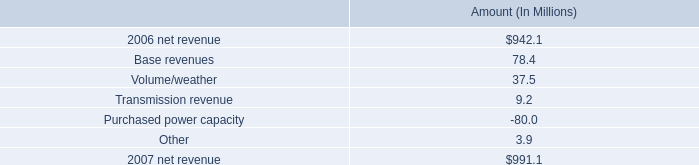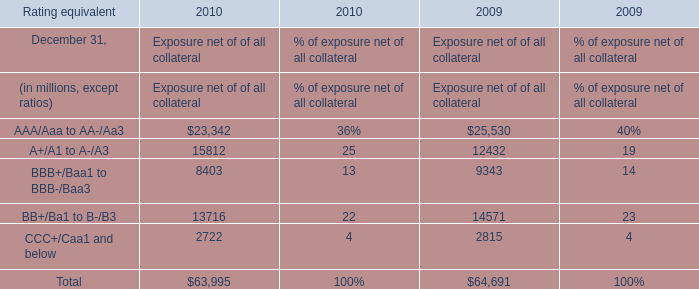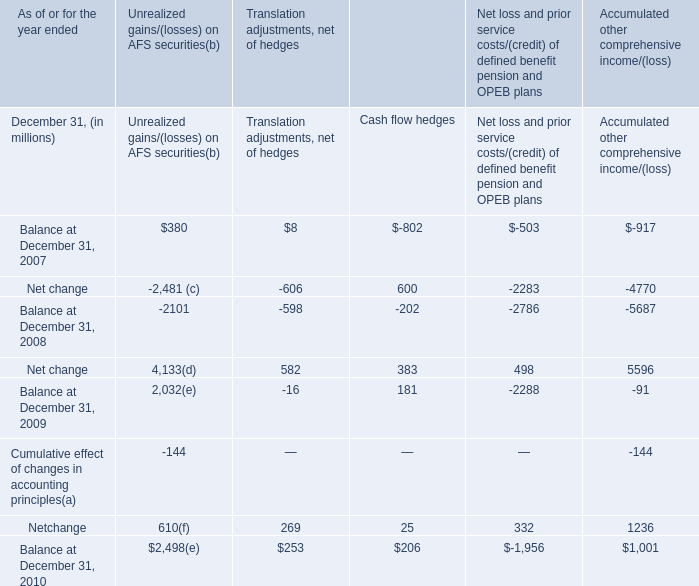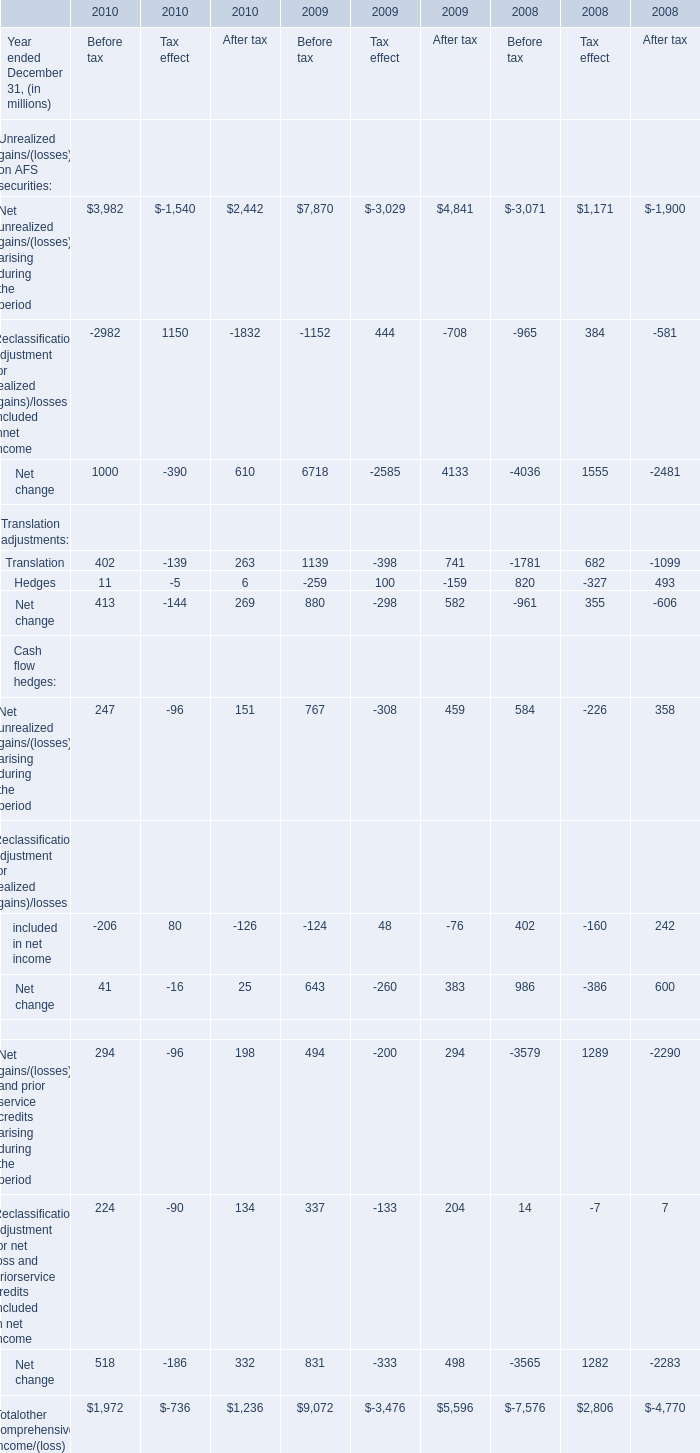What's the growth rate of Translation for After tax in 2010? 
Computations: ((263 - 741) / 741)
Answer: -0.64507. 